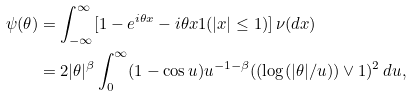<formula> <loc_0><loc_0><loc_500><loc_500>\psi ( \theta ) & = \int _ { - \infty } ^ { \infty } [ 1 - e ^ { i \theta x } - i \theta x 1 ( | x | \leq 1 ) ] \, \nu ( d x ) \\ & = 2 | \theta | ^ { \beta } \int _ { 0 } ^ { \infty } ( 1 - \cos u ) u ^ { - 1 - \beta } ( ( \log ( | \theta | / u ) ) \vee 1 ) ^ { 2 } \, d u ,</formula> 